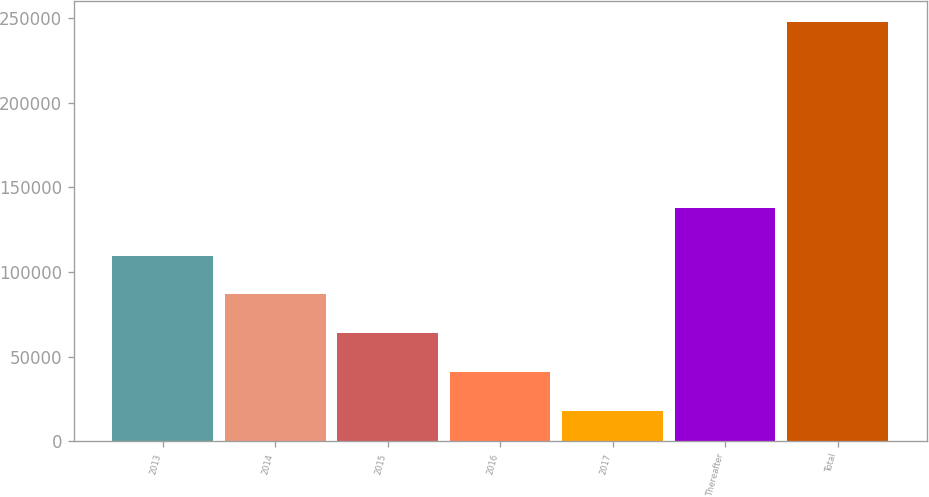<chart> <loc_0><loc_0><loc_500><loc_500><bar_chart><fcel>2013<fcel>2014<fcel>2015<fcel>2016<fcel>2017<fcel>Thereafter<fcel>Total<nl><fcel>109781<fcel>86767.3<fcel>63753.2<fcel>40739.1<fcel>17725<fcel>137978<fcel>247866<nl></chart> 